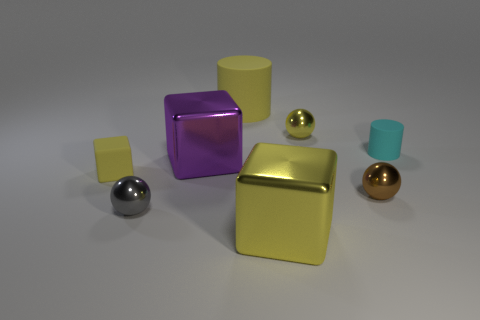What number of tiny metal spheres are in front of the small matte thing that is right of the gray metal sphere? Observing the arrangement in the image, there are two small metal spheres positioned in front of the small matte block, which is to the right of the gray metal sphere. 